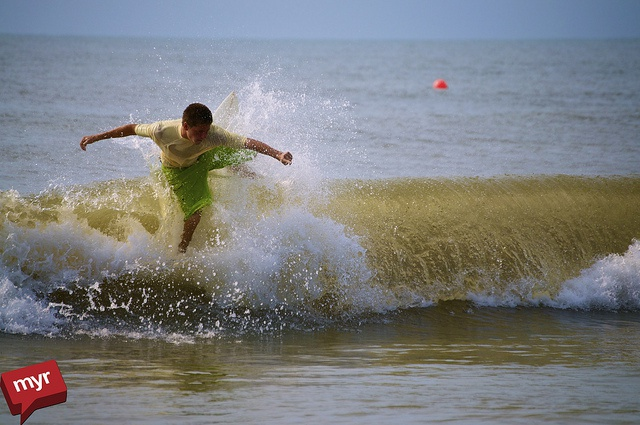Describe the objects in this image and their specific colors. I can see people in gray, olive, black, maroon, and darkgreen tones, surfboard in gray, darkgray, and lightgray tones, and sports ball in gray, darkgray, lightpink, salmon, and brown tones in this image. 